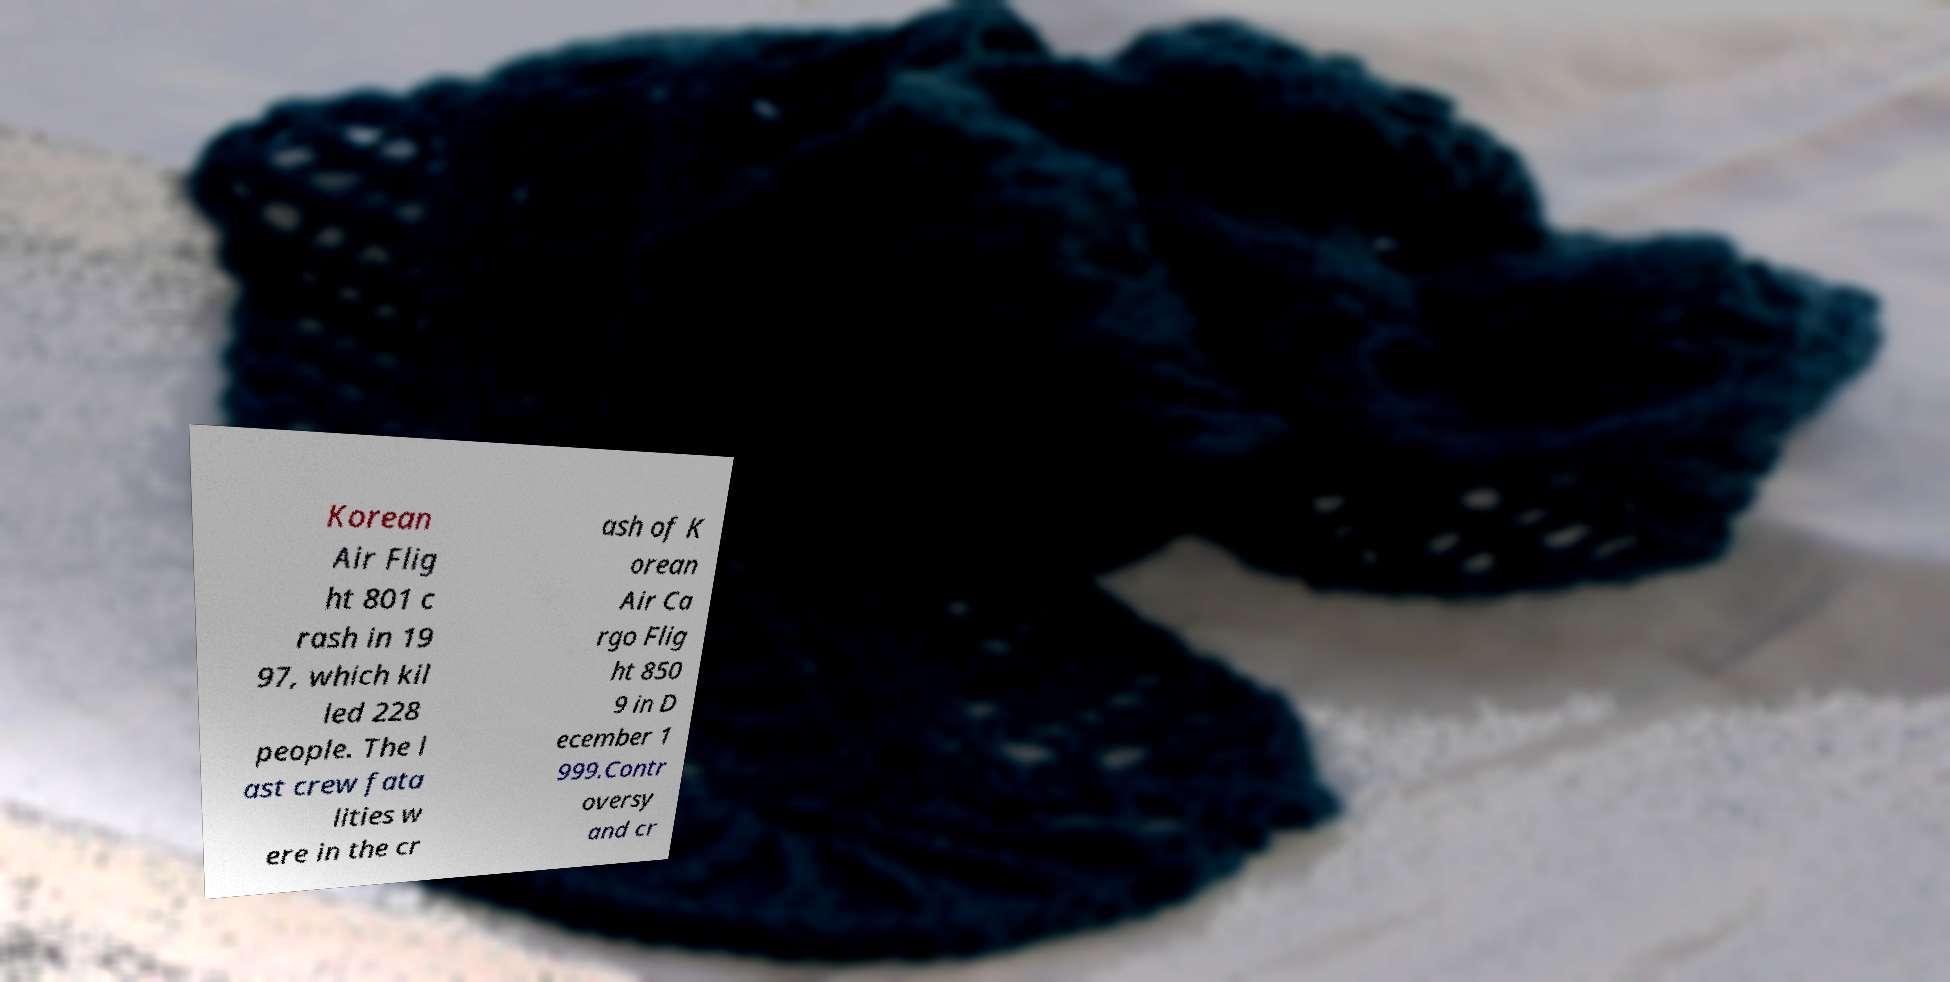Please identify and transcribe the text found in this image. Korean Air Flig ht 801 c rash in 19 97, which kil led 228 people. The l ast crew fata lities w ere in the cr ash of K orean Air Ca rgo Flig ht 850 9 in D ecember 1 999.Contr oversy and cr 